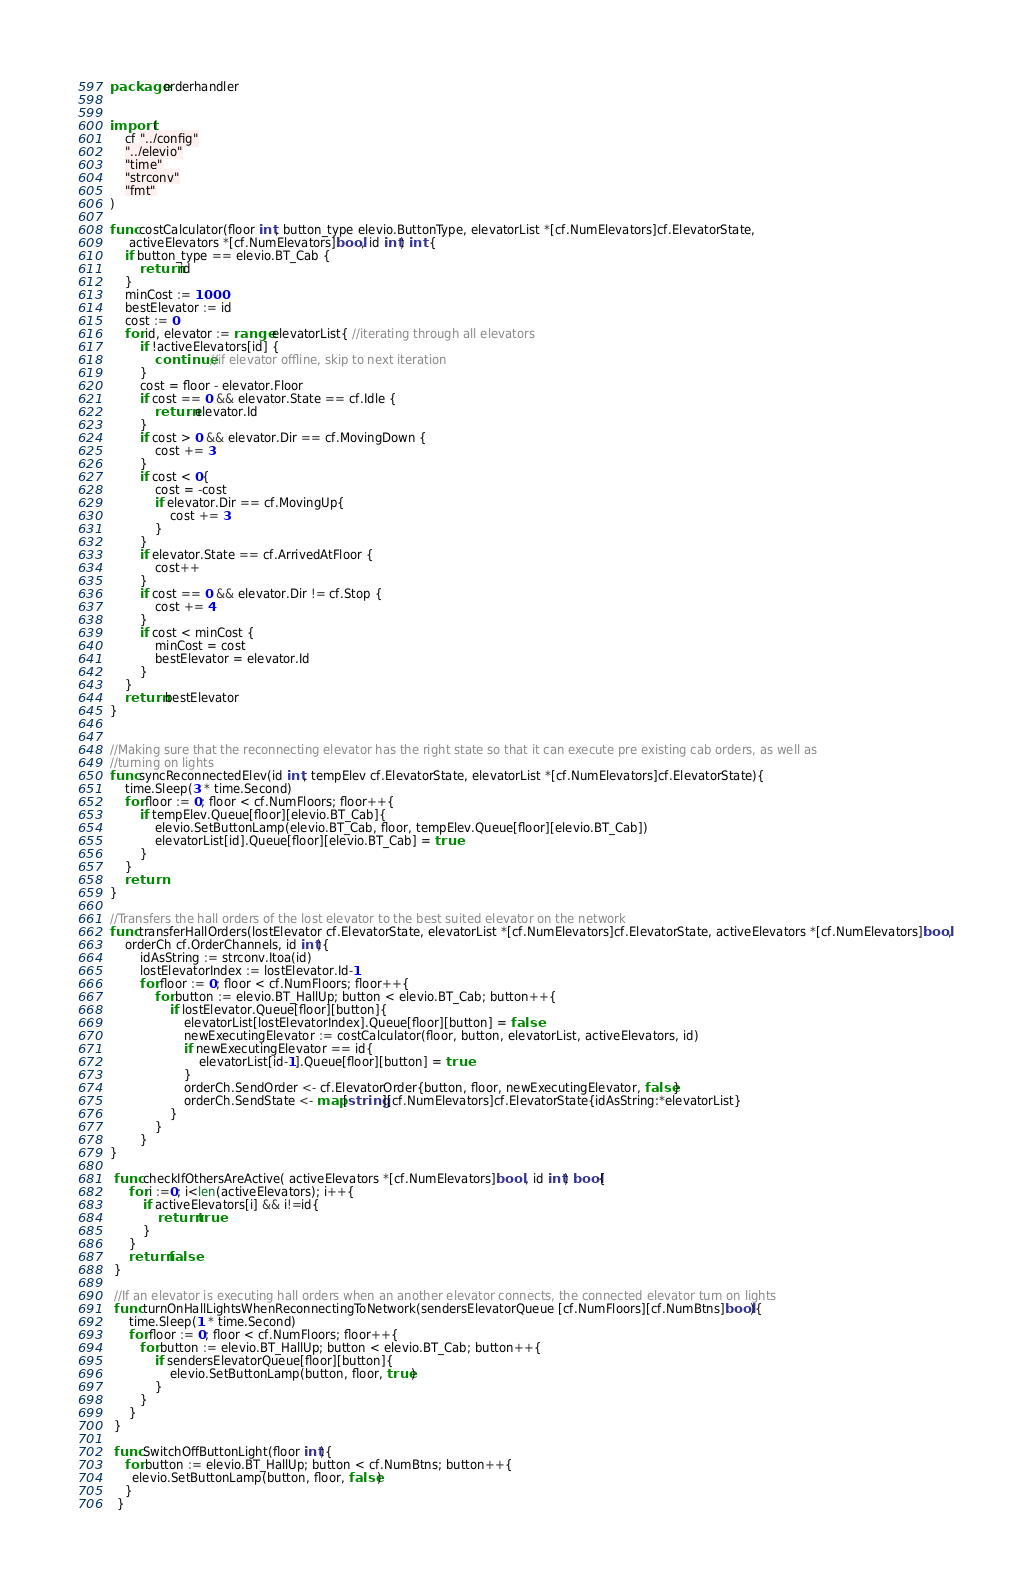Convert code to text. <code><loc_0><loc_0><loc_500><loc_500><_Go_>package orderhandler


import (
	cf "../config"
 	"../elevio"
	"time"
	"strconv"
	"fmt"
)

func costCalculator(floor int, button_type elevio.ButtonType, elevatorList *[cf.NumElevators]cf.ElevatorState,
	 activeElevators *[cf.NumElevators]bool, id int) int {
	if button_type == elevio.BT_Cab {
		return id
	}
	minCost := 1000
	bestElevator := id
	cost := 0
	for id, elevator := range elevatorList{ //iterating through all elevators
		if !activeElevators[id] {
			continue //if elevator offline, skip to next iteration
		}
		cost = floor - elevator.Floor
		if cost == 0 && elevator.State == cf.Idle {
			return elevator.Id
		}
		if cost > 0 && elevator.Dir == cf.MovingDown {
			cost += 3
		}
		if cost < 0{
			cost = -cost
			if elevator.Dir == cf.MovingUp{
				cost += 3
			}
		}
		if elevator.State == cf.ArrivedAtFloor {
			cost++
		}
		if cost == 0 && elevator.Dir != cf.Stop {
			cost += 4
		}
		if cost < minCost {
			minCost = cost
			bestElevator = elevator.Id
		}
	}
	return bestElevator
}


//Making sure that the reconnecting elevator has the right state so that it can execute pre existing cab orders, as well as
//turning on lights
func syncReconnectedElev(id int, tempElev cf.ElevatorState, elevatorList *[cf.NumElevators]cf.ElevatorState){
	time.Sleep(3 * time.Second)
	for floor := 0; floor < cf.NumFloors; floor++{
		if tempElev.Queue[floor][elevio.BT_Cab]{
			elevio.SetButtonLamp(elevio.BT_Cab, floor, tempElev.Queue[floor][elevio.BT_Cab])
			elevatorList[id].Queue[floor][elevio.BT_Cab] = true
		}
	}
	return
}

//Transfers the hall orders of the lost elevator to the best suited elevator on the network
func transferHallOrders(lostElevator cf.ElevatorState, elevatorList *[cf.NumElevators]cf.ElevatorState, activeElevators *[cf.NumElevators]bool,
	orderCh cf.OrderChannels, id int){
		idAsString := strconv.Itoa(id)
		lostElevatorIndex := lostElevator.Id-1
		for floor := 0; floor < cf.NumFloors; floor++{
			for button := elevio.BT_HallUp; button < elevio.BT_Cab; button++{
				if lostElevator.Queue[floor][button]{
					elevatorList[lostElevatorIndex].Queue[floor][button] = false
					newExecutingElevator := costCalculator(floor, button, elevatorList, activeElevators, id)
					if newExecutingElevator == id{
						elevatorList[id-1].Queue[floor][button] = true
					}
					orderCh.SendOrder <- cf.ElevatorOrder{button, floor, newExecutingElevator, false}
					orderCh.SendState <- map[string][cf.NumElevators]cf.ElevatorState{idAsString:*elevatorList}
				}
			}
		}
}

 func checkIfOthersAreActive( activeElevators *[cf.NumElevators]bool , id int) bool{
	 for i :=0; i<len(activeElevators); i++{
		 if activeElevators[i] && i!=id{
			 return true
		 }
	 }
	 return false
 }

 //If an elevator is executing hall orders when an another elevator connects, the connected elevator turn on lights
 func turnOnHallLightsWhenReconnectingToNetwork(sendersElevatorQueue [cf.NumFloors][cf.NumBtns]bool){
	 time.Sleep(1 * time.Second)
	 for floor := 0; floor < cf.NumFloors; floor++{
		for button := elevio.BT_HallUp; button < elevio.BT_Cab; button++{
			if sendersElevatorQueue[floor][button]{
				elevio.SetButtonLamp(button, floor, true)
			}
		}
	 }
 }

 func SwitchOffButtonLight(floor int){
	for button := elevio.BT_HallUp; button < cf.NumBtns; button++{
	  elevio.SetButtonLamp(button, floor, false)
	}
  }</code> 